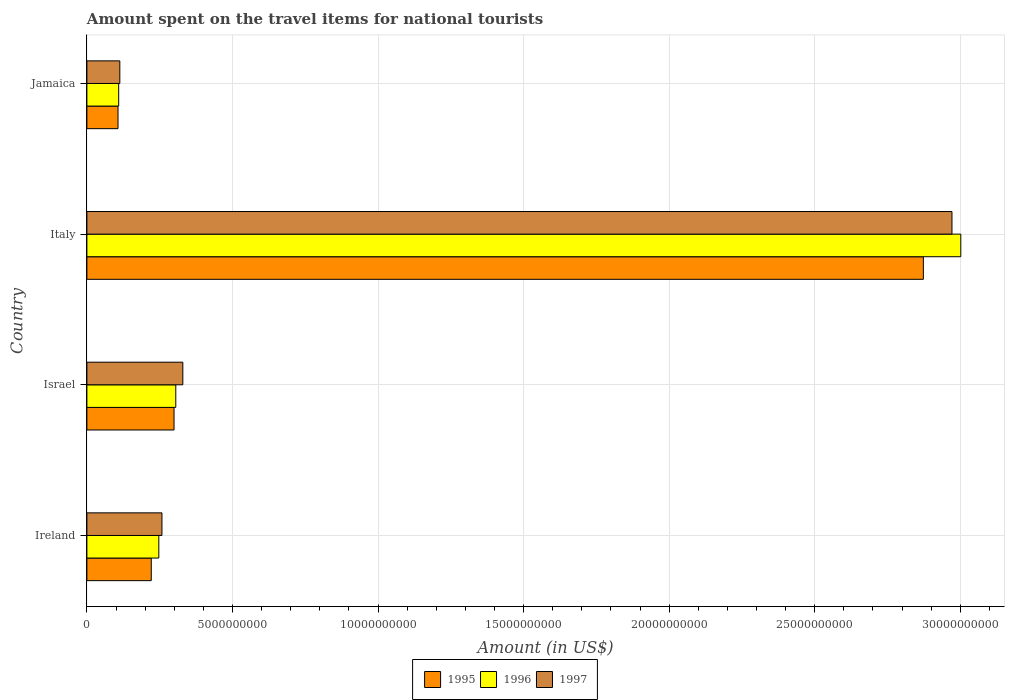How many different coloured bars are there?
Offer a terse response. 3. Are the number of bars on each tick of the Y-axis equal?
Ensure brevity in your answer.  Yes. What is the label of the 4th group of bars from the top?
Provide a succinct answer. Ireland. In how many cases, is the number of bars for a given country not equal to the number of legend labels?
Give a very brief answer. 0. What is the amount spent on the travel items for national tourists in 1996 in Italy?
Offer a terse response. 3.00e+1. Across all countries, what is the maximum amount spent on the travel items for national tourists in 1996?
Make the answer very short. 3.00e+1. Across all countries, what is the minimum amount spent on the travel items for national tourists in 1995?
Give a very brief answer. 1.07e+09. In which country was the amount spent on the travel items for national tourists in 1996 minimum?
Provide a succinct answer. Jamaica. What is the total amount spent on the travel items for national tourists in 1995 in the graph?
Offer a very short reply. 3.50e+1. What is the difference between the amount spent on the travel items for national tourists in 1996 in Ireland and that in Jamaica?
Make the answer very short. 1.38e+09. What is the difference between the amount spent on the travel items for national tourists in 1997 in Ireland and the amount spent on the travel items for national tourists in 1996 in Jamaica?
Give a very brief answer. 1.49e+09. What is the average amount spent on the travel items for national tourists in 1996 per country?
Offer a terse response. 9.16e+09. What is the difference between the amount spent on the travel items for national tourists in 1995 and amount spent on the travel items for national tourists in 1997 in Israel?
Provide a short and direct response. -3.02e+08. What is the ratio of the amount spent on the travel items for national tourists in 1997 in Ireland to that in Jamaica?
Ensure brevity in your answer.  2.28. What is the difference between the highest and the second highest amount spent on the travel items for national tourists in 1995?
Make the answer very short. 2.57e+1. What is the difference between the highest and the lowest amount spent on the travel items for national tourists in 1997?
Keep it short and to the point. 2.86e+1. Is it the case that in every country, the sum of the amount spent on the travel items for national tourists in 1997 and amount spent on the travel items for national tourists in 1995 is greater than the amount spent on the travel items for national tourists in 1996?
Offer a terse response. Yes. How many bars are there?
Offer a very short reply. 12. Are all the bars in the graph horizontal?
Your response must be concise. Yes. How many countries are there in the graph?
Offer a terse response. 4. Are the values on the major ticks of X-axis written in scientific E-notation?
Your answer should be very brief. No. Does the graph contain any zero values?
Your answer should be compact. No. Does the graph contain grids?
Offer a terse response. Yes. Where does the legend appear in the graph?
Keep it short and to the point. Bottom center. What is the title of the graph?
Your answer should be very brief. Amount spent on the travel items for national tourists. Does "2010" appear as one of the legend labels in the graph?
Give a very brief answer. No. What is the label or title of the X-axis?
Your answer should be very brief. Amount (in US$). What is the label or title of the Y-axis?
Offer a very short reply. Country. What is the Amount (in US$) of 1995 in Ireland?
Provide a succinct answer. 2.21e+09. What is the Amount (in US$) in 1996 in Ireland?
Provide a short and direct response. 2.47e+09. What is the Amount (in US$) in 1997 in Ireland?
Keep it short and to the point. 2.58e+09. What is the Amount (in US$) of 1995 in Israel?
Make the answer very short. 2.99e+09. What is the Amount (in US$) in 1996 in Israel?
Offer a very short reply. 3.05e+09. What is the Amount (in US$) in 1997 in Israel?
Your answer should be compact. 3.30e+09. What is the Amount (in US$) in 1995 in Italy?
Ensure brevity in your answer.  2.87e+1. What is the Amount (in US$) of 1996 in Italy?
Ensure brevity in your answer.  3.00e+1. What is the Amount (in US$) in 1997 in Italy?
Provide a succinct answer. 2.97e+1. What is the Amount (in US$) in 1995 in Jamaica?
Provide a short and direct response. 1.07e+09. What is the Amount (in US$) of 1996 in Jamaica?
Make the answer very short. 1.09e+09. What is the Amount (in US$) of 1997 in Jamaica?
Provide a succinct answer. 1.13e+09. Across all countries, what is the maximum Amount (in US$) of 1995?
Your response must be concise. 2.87e+1. Across all countries, what is the maximum Amount (in US$) of 1996?
Give a very brief answer. 3.00e+1. Across all countries, what is the maximum Amount (in US$) in 1997?
Give a very brief answer. 2.97e+1. Across all countries, what is the minimum Amount (in US$) of 1995?
Keep it short and to the point. 1.07e+09. Across all countries, what is the minimum Amount (in US$) of 1996?
Keep it short and to the point. 1.09e+09. Across all countries, what is the minimum Amount (in US$) of 1997?
Your response must be concise. 1.13e+09. What is the total Amount (in US$) of 1995 in the graph?
Ensure brevity in your answer.  3.50e+1. What is the total Amount (in US$) in 1996 in the graph?
Your answer should be compact. 3.66e+1. What is the total Amount (in US$) in 1997 in the graph?
Ensure brevity in your answer.  3.67e+1. What is the difference between the Amount (in US$) in 1995 in Ireland and that in Israel?
Provide a short and direct response. -7.82e+08. What is the difference between the Amount (in US$) in 1996 in Ireland and that in Israel?
Offer a terse response. -5.83e+08. What is the difference between the Amount (in US$) of 1997 in Ireland and that in Israel?
Keep it short and to the point. -7.17e+08. What is the difference between the Amount (in US$) in 1995 in Ireland and that in Italy?
Make the answer very short. -2.65e+1. What is the difference between the Amount (in US$) of 1996 in Ireland and that in Italy?
Keep it short and to the point. -2.75e+1. What is the difference between the Amount (in US$) in 1997 in Ireland and that in Italy?
Ensure brevity in your answer.  -2.71e+1. What is the difference between the Amount (in US$) of 1995 in Ireland and that in Jamaica?
Your answer should be very brief. 1.14e+09. What is the difference between the Amount (in US$) of 1996 in Ireland and that in Jamaica?
Your response must be concise. 1.38e+09. What is the difference between the Amount (in US$) in 1997 in Ireland and that in Jamaica?
Provide a succinct answer. 1.45e+09. What is the difference between the Amount (in US$) of 1995 in Israel and that in Italy?
Your answer should be very brief. -2.57e+1. What is the difference between the Amount (in US$) of 1996 in Israel and that in Italy?
Your answer should be very brief. -2.70e+1. What is the difference between the Amount (in US$) in 1997 in Israel and that in Italy?
Keep it short and to the point. -2.64e+1. What is the difference between the Amount (in US$) in 1995 in Israel and that in Jamaica?
Make the answer very short. 1.92e+09. What is the difference between the Amount (in US$) of 1996 in Israel and that in Jamaica?
Provide a succinct answer. 1.96e+09. What is the difference between the Amount (in US$) in 1997 in Israel and that in Jamaica?
Keep it short and to the point. 2.16e+09. What is the difference between the Amount (in US$) in 1995 in Italy and that in Jamaica?
Provide a short and direct response. 2.77e+1. What is the difference between the Amount (in US$) of 1996 in Italy and that in Jamaica?
Keep it short and to the point. 2.89e+1. What is the difference between the Amount (in US$) of 1997 in Italy and that in Jamaica?
Keep it short and to the point. 2.86e+1. What is the difference between the Amount (in US$) of 1995 in Ireland and the Amount (in US$) of 1996 in Israel?
Give a very brief answer. -8.42e+08. What is the difference between the Amount (in US$) of 1995 in Ireland and the Amount (in US$) of 1997 in Israel?
Your response must be concise. -1.08e+09. What is the difference between the Amount (in US$) of 1996 in Ireland and the Amount (in US$) of 1997 in Israel?
Provide a short and direct response. -8.25e+08. What is the difference between the Amount (in US$) in 1995 in Ireland and the Amount (in US$) in 1996 in Italy?
Keep it short and to the point. -2.78e+1. What is the difference between the Amount (in US$) in 1995 in Ireland and the Amount (in US$) in 1997 in Italy?
Offer a very short reply. -2.75e+1. What is the difference between the Amount (in US$) of 1996 in Ireland and the Amount (in US$) of 1997 in Italy?
Your answer should be compact. -2.72e+1. What is the difference between the Amount (in US$) in 1995 in Ireland and the Amount (in US$) in 1996 in Jamaica?
Offer a terse response. 1.12e+09. What is the difference between the Amount (in US$) of 1995 in Ireland and the Amount (in US$) of 1997 in Jamaica?
Provide a succinct answer. 1.08e+09. What is the difference between the Amount (in US$) of 1996 in Ireland and the Amount (in US$) of 1997 in Jamaica?
Your answer should be very brief. 1.34e+09. What is the difference between the Amount (in US$) in 1995 in Israel and the Amount (in US$) in 1996 in Italy?
Your answer should be very brief. -2.70e+1. What is the difference between the Amount (in US$) in 1995 in Israel and the Amount (in US$) in 1997 in Italy?
Make the answer very short. -2.67e+1. What is the difference between the Amount (in US$) of 1996 in Israel and the Amount (in US$) of 1997 in Italy?
Your answer should be compact. -2.67e+1. What is the difference between the Amount (in US$) in 1995 in Israel and the Amount (in US$) in 1996 in Jamaica?
Your answer should be very brief. 1.90e+09. What is the difference between the Amount (in US$) in 1995 in Israel and the Amount (in US$) in 1997 in Jamaica?
Make the answer very short. 1.86e+09. What is the difference between the Amount (in US$) of 1996 in Israel and the Amount (in US$) of 1997 in Jamaica?
Keep it short and to the point. 1.92e+09. What is the difference between the Amount (in US$) of 1995 in Italy and the Amount (in US$) of 1996 in Jamaica?
Provide a succinct answer. 2.76e+1. What is the difference between the Amount (in US$) in 1995 in Italy and the Amount (in US$) in 1997 in Jamaica?
Ensure brevity in your answer.  2.76e+1. What is the difference between the Amount (in US$) of 1996 in Italy and the Amount (in US$) of 1997 in Jamaica?
Keep it short and to the point. 2.89e+1. What is the average Amount (in US$) in 1995 per country?
Provide a succinct answer. 8.75e+09. What is the average Amount (in US$) in 1996 per country?
Provide a succinct answer. 9.16e+09. What is the average Amount (in US$) in 1997 per country?
Keep it short and to the point. 9.18e+09. What is the difference between the Amount (in US$) of 1995 and Amount (in US$) of 1996 in Ireland?
Your response must be concise. -2.59e+08. What is the difference between the Amount (in US$) in 1995 and Amount (in US$) in 1997 in Ireland?
Ensure brevity in your answer.  -3.67e+08. What is the difference between the Amount (in US$) in 1996 and Amount (in US$) in 1997 in Ireland?
Your response must be concise. -1.08e+08. What is the difference between the Amount (in US$) of 1995 and Amount (in US$) of 1996 in Israel?
Provide a short and direct response. -6.00e+07. What is the difference between the Amount (in US$) of 1995 and Amount (in US$) of 1997 in Israel?
Your answer should be compact. -3.02e+08. What is the difference between the Amount (in US$) of 1996 and Amount (in US$) of 1997 in Israel?
Keep it short and to the point. -2.42e+08. What is the difference between the Amount (in US$) of 1995 and Amount (in US$) of 1996 in Italy?
Your answer should be very brief. -1.29e+09. What is the difference between the Amount (in US$) in 1995 and Amount (in US$) in 1997 in Italy?
Your answer should be compact. -9.83e+08. What is the difference between the Amount (in US$) of 1996 and Amount (in US$) of 1997 in Italy?
Your response must be concise. 3.03e+08. What is the difference between the Amount (in US$) of 1995 and Amount (in US$) of 1996 in Jamaica?
Offer a terse response. -2.30e+07. What is the difference between the Amount (in US$) of 1995 and Amount (in US$) of 1997 in Jamaica?
Ensure brevity in your answer.  -6.20e+07. What is the difference between the Amount (in US$) in 1996 and Amount (in US$) in 1997 in Jamaica?
Ensure brevity in your answer.  -3.90e+07. What is the ratio of the Amount (in US$) of 1995 in Ireland to that in Israel?
Offer a very short reply. 0.74. What is the ratio of the Amount (in US$) in 1996 in Ireland to that in Israel?
Give a very brief answer. 0.81. What is the ratio of the Amount (in US$) of 1997 in Ireland to that in Israel?
Your answer should be compact. 0.78. What is the ratio of the Amount (in US$) of 1995 in Ireland to that in Italy?
Give a very brief answer. 0.08. What is the ratio of the Amount (in US$) of 1996 in Ireland to that in Italy?
Provide a succinct answer. 0.08. What is the ratio of the Amount (in US$) in 1997 in Ireland to that in Italy?
Your response must be concise. 0.09. What is the ratio of the Amount (in US$) of 1995 in Ireland to that in Jamaica?
Your answer should be very brief. 2.07. What is the ratio of the Amount (in US$) of 1996 in Ireland to that in Jamaica?
Your answer should be very brief. 2.26. What is the ratio of the Amount (in US$) of 1997 in Ireland to that in Jamaica?
Offer a terse response. 2.28. What is the ratio of the Amount (in US$) in 1995 in Israel to that in Italy?
Offer a very short reply. 0.1. What is the ratio of the Amount (in US$) of 1996 in Israel to that in Italy?
Give a very brief answer. 0.1. What is the ratio of the Amount (in US$) in 1997 in Israel to that in Italy?
Ensure brevity in your answer.  0.11. What is the ratio of the Amount (in US$) in 1995 in Israel to that in Jamaica?
Offer a very short reply. 2.8. What is the ratio of the Amount (in US$) of 1996 in Israel to that in Jamaica?
Your answer should be very brief. 2.8. What is the ratio of the Amount (in US$) in 1997 in Israel to that in Jamaica?
Give a very brief answer. 2.91. What is the ratio of the Amount (in US$) of 1995 in Italy to that in Jamaica?
Your answer should be very brief. 26.88. What is the ratio of the Amount (in US$) of 1996 in Italy to that in Jamaica?
Ensure brevity in your answer.  27.49. What is the ratio of the Amount (in US$) in 1997 in Italy to that in Jamaica?
Ensure brevity in your answer.  26.27. What is the difference between the highest and the second highest Amount (in US$) in 1995?
Offer a terse response. 2.57e+1. What is the difference between the highest and the second highest Amount (in US$) of 1996?
Provide a succinct answer. 2.70e+1. What is the difference between the highest and the second highest Amount (in US$) in 1997?
Offer a very short reply. 2.64e+1. What is the difference between the highest and the lowest Amount (in US$) of 1995?
Make the answer very short. 2.77e+1. What is the difference between the highest and the lowest Amount (in US$) in 1996?
Offer a very short reply. 2.89e+1. What is the difference between the highest and the lowest Amount (in US$) of 1997?
Provide a succinct answer. 2.86e+1. 